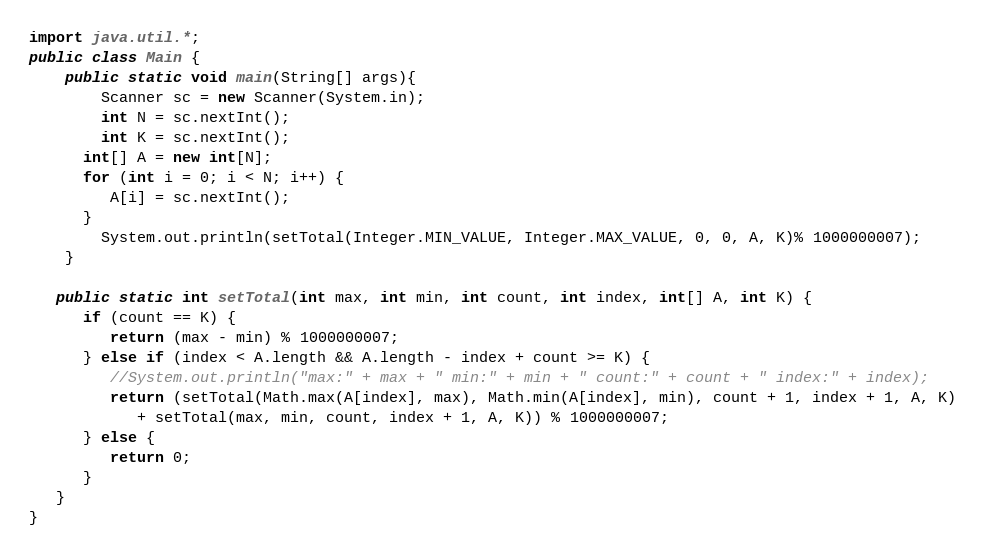<code> <loc_0><loc_0><loc_500><loc_500><_Java_>import java.util.*;
public class Main {
	public static void main(String[] args){
		Scanner sc = new Scanner(System.in);
		int N = sc.nextInt();
		int K = sc.nextInt();
      int[] A = new int[N];
      for (int i = 0; i < N; i++) {
         A[i] = sc.nextInt();
      }
		System.out.println(setTotal(Integer.MIN_VALUE, Integer.MAX_VALUE, 0, 0, A, K)% 1000000007);
	}
   
   public static int setTotal(int max, int min, int count, int index, int[] A, int K) {
      if (count == K) {
         return (max - min) % 1000000007;
      } else if (index < A.length && A.length - index + count >= K) {
         //System.out.println("max:" + max + " min:" + min + " count:" + count + " index:" + index);
         return (setTotal(Math.max(A[index], max), Math.min(A[index], min), count + 1, index + 1, A, K)
            + setTotal(max, min, count, index + 1, A, K)) % 1000000007;
      } else {
         return 0;
      }
   }
}</code> 